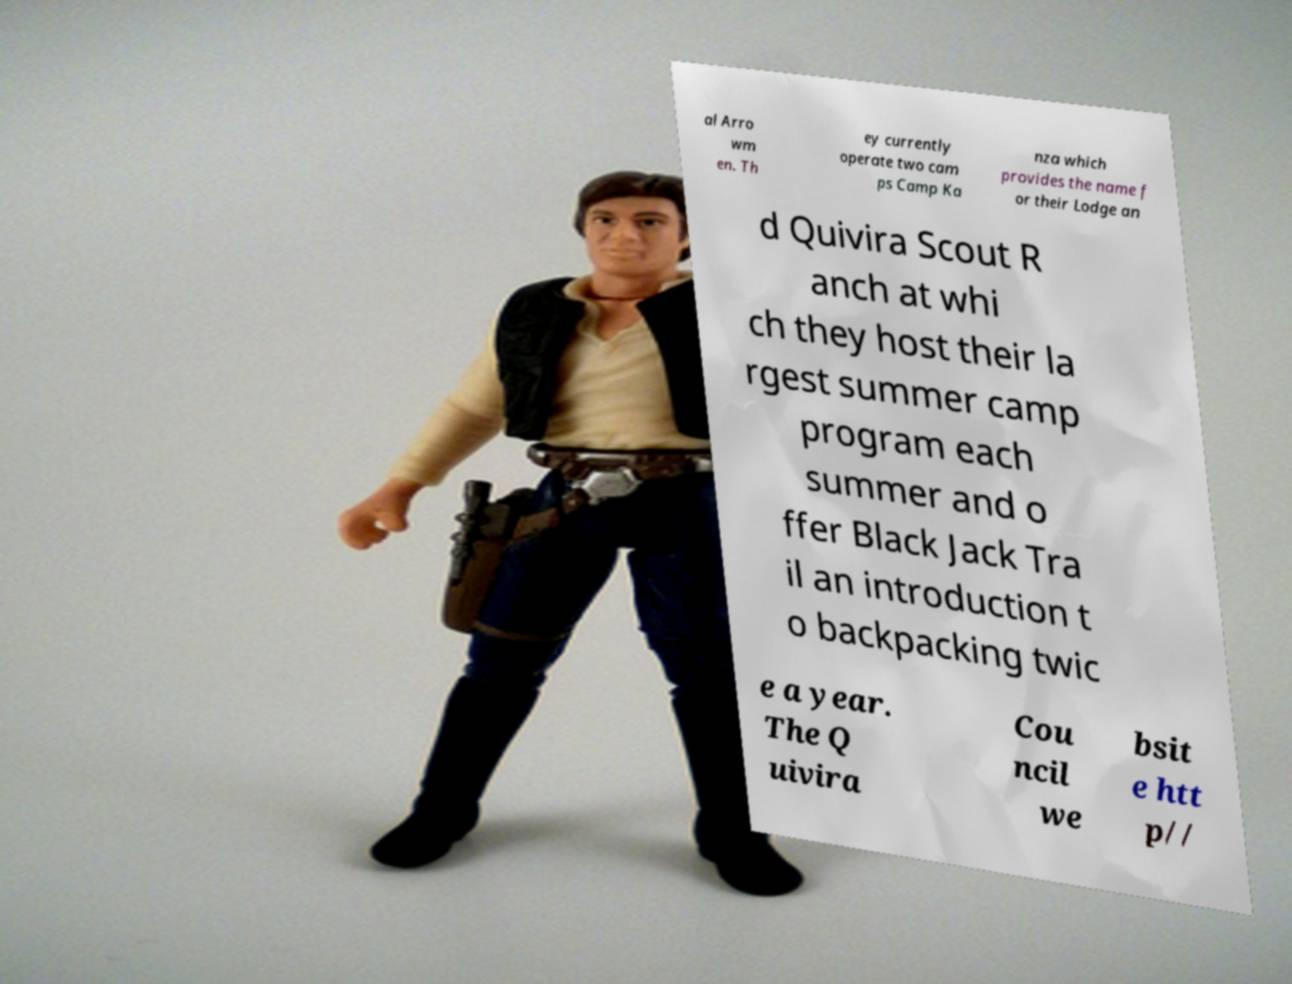Could you extract and type out the text from this image? al Arro wm en. Th ey currently operate two cam ps Camp Ka nza which provides the name f or their Lodge an d Quivira Scout R anch at whi ch they host their la rgest summer camp program each summer and o ffer Black Jack Tra il an introduction t o backpacking twic e a year. The Q uivira Cou ncil we bsit e htt p// 